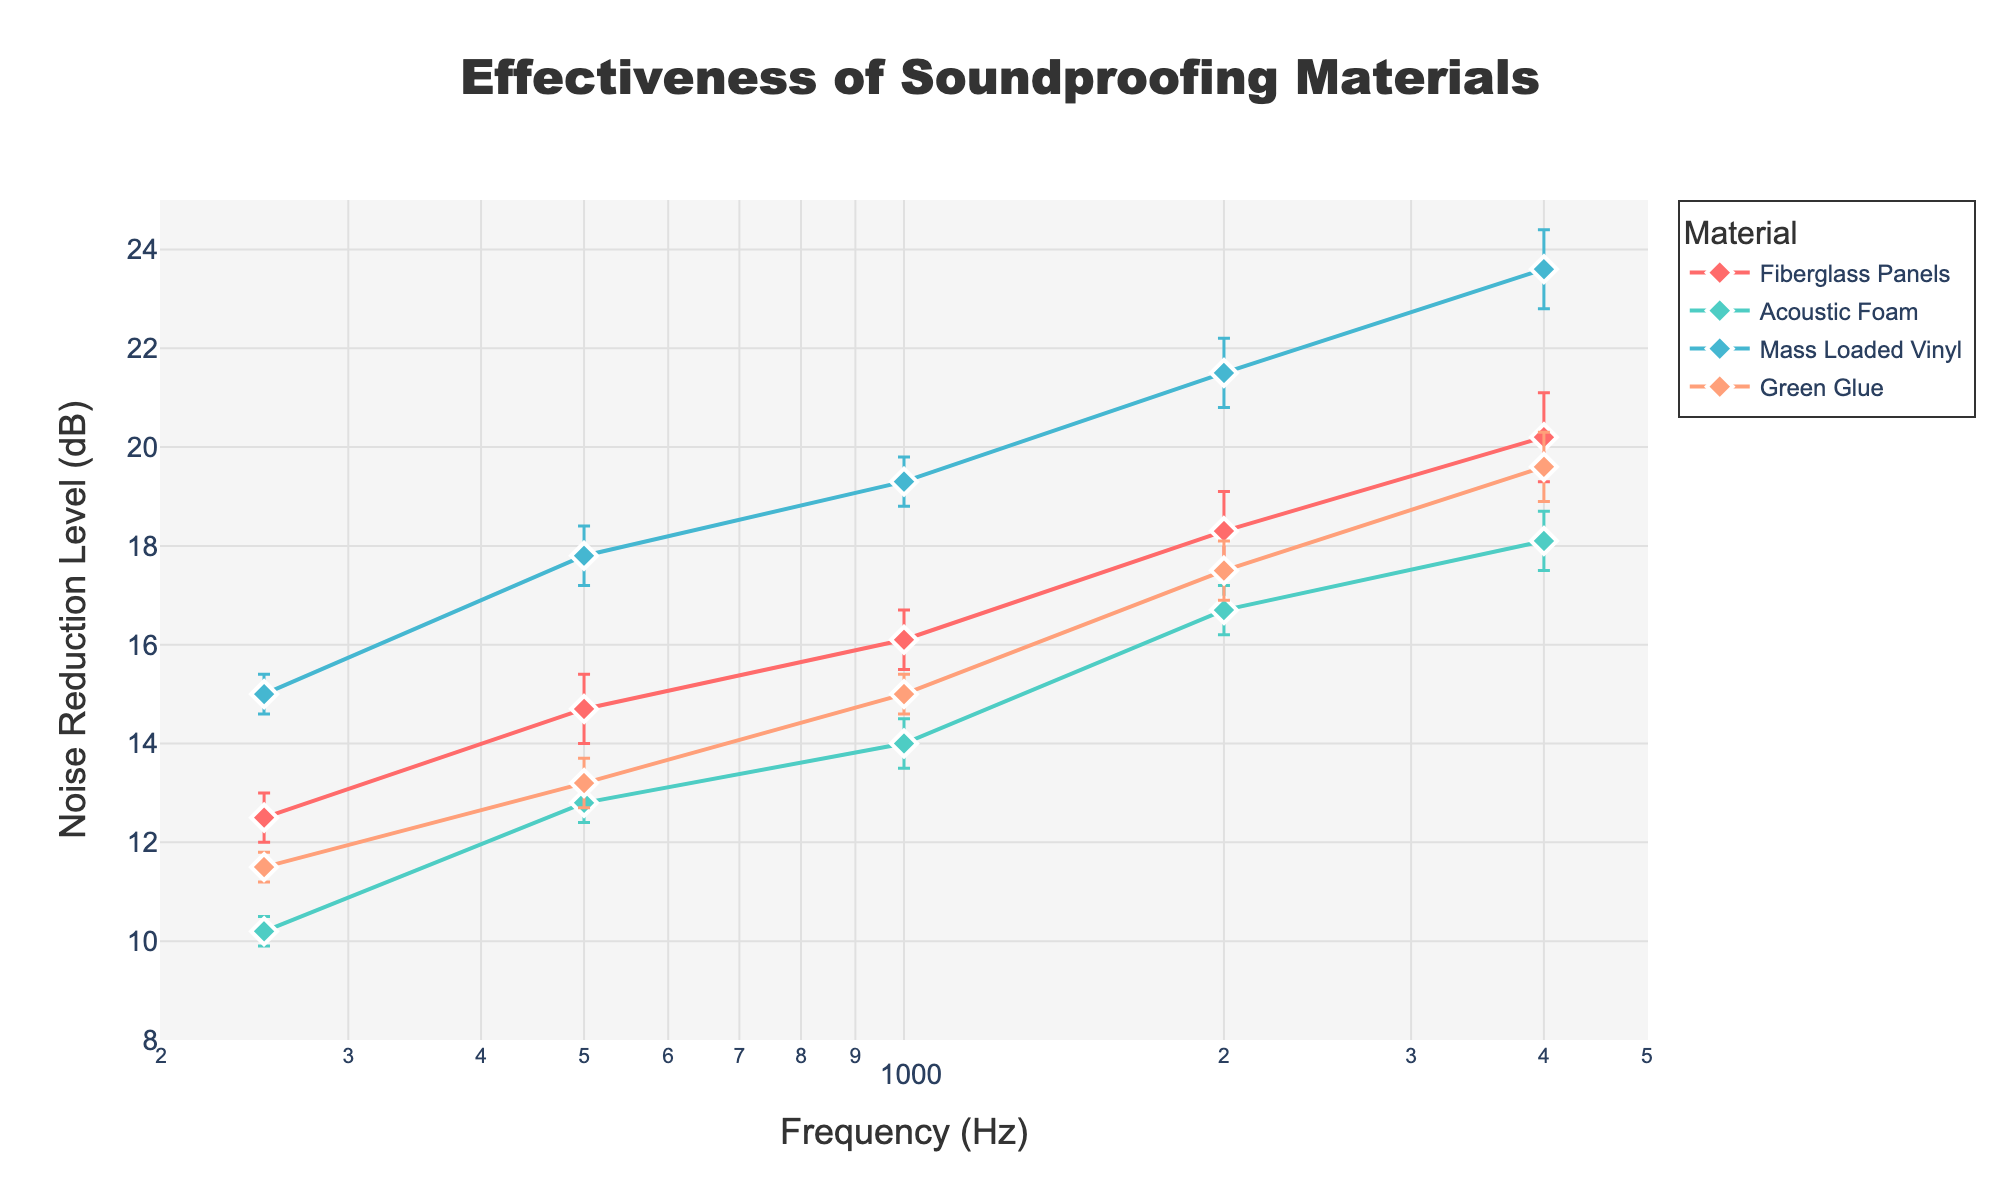What is the title of the figure? The title of the figure is positioned at the top and provides an overview of what the figure represents.
Answer: Effectiveness of Soundproofing Materials Which material shows the highest noise reduction level at 1000 Hz? By locating the frequency of 1000 Hz along the x-axis and observing the y-values for each material, we can identify the highest point.
Answer: Mass Loaded Vinyl How does the noise reduction level of Green Glue compare to Acoustic Foam at 2000 Hz? At 2000 Hz on the x-axis, compare the y-values (Noise Reduction Level) for Green Glue and Acoustic Foam.
Answer: Green Glue has a higher reduction level than Acoustic Foam What is the range of Noise Reduction Levels (dB) shown in the figure? By observing the lowest and highest points on the y-axis (Noise Reduction Level), we can determine the range. The lowest value is for Acoustic Foam at 250 Hz, and the highest is for Mass Loaded Vinyl at 4000 Hz.
Answer: 10.2 dB to 23.6 dB Which material has the least error margin in the Noise Reduction Level at 250 Hz? By looking at the error bars (vertical lines) at 250 Hz, identify which one is the shortest.
Answer: Green Glue What is the mean noise reduction level for Fiberglass Panels across all frequencies? Locate the noise reduction levels for Fiberglass Panels at each frequency, sum them up, and divide by the number of frequencies (5). Mean = (12.5 + 14.7 + 16.1 + 18.3 + 20.2) / 5
Answer: 16.36 dB Between which frequencies does Acoustic Foam show the most significant increase in noise reduction level? By observing the slope of the line connecting Acoustic Foam points, the largest increase occurs where the line is steepest.
Answer: 250 Hz to 1000 Hz How does the error margin of Mass Loaded Vinyl change as frequency increases? Observing the length of error bars for Mass Loaded Vinyl at different frequencies, note the trend as frequency goes from 250 Hz to 4000 Hz.
Answer: Error margin increases Is the Noise Reduction Level for Green Glue at 500 Hz within the error margin of Fiberglass Panels at 500 Hz? Check if the noise reduction level of Green Glue at 500 Hz (13.2 dB ± 0.5 dB) falls within the range of Fiberglass Panels at 500 Hz (14.7 dB ± 0.7 dB).
Answer: Yes 